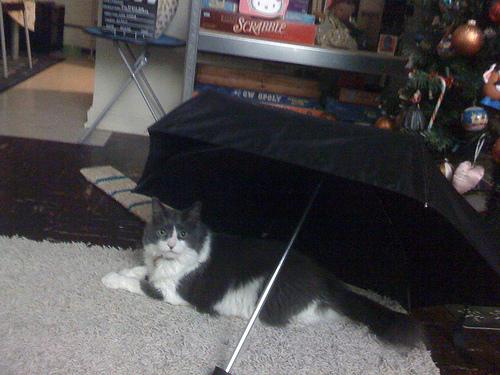What color is the car?
Concise answer only. Gray. What holiday will be soon?
Give a very brief answer. Christmas. Where is the cat sitting?
Write a very short answer. Floor. 